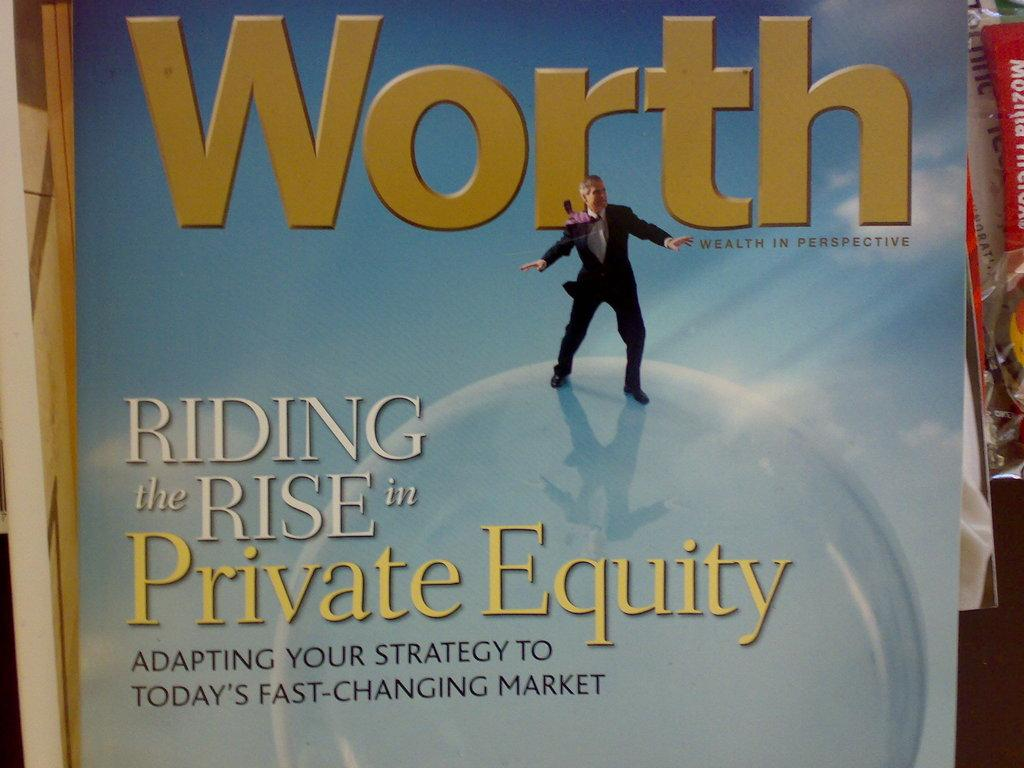<image>
Describe the image concisely. A title page for Worth with a focus on Riding the Rise of Private Equity. 